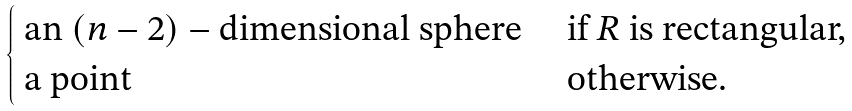Convert formula to latex. <formula><loc_0><loc_0><loc_500><loc_500>\begin{cases} \text { an } ( n - 2 ) - \text {dimensional sphere} & \text { if } R \text { is rectangular,} \\ \text { a point } & \text { otherwise.} \\ \end{cases}</formula> 